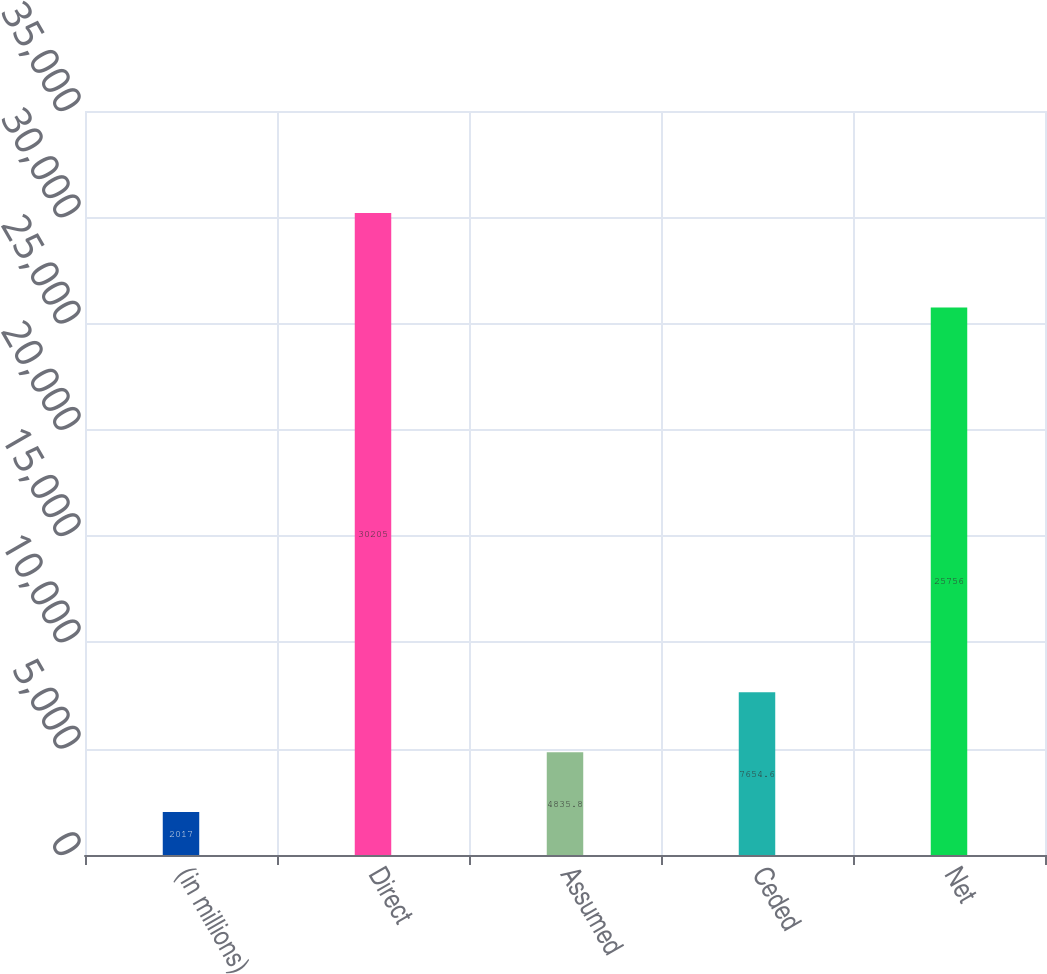Convert chart. <chart><loc_0><loc_0><loc_500><loc_500><bar_chart><fcel>(in millions)<fcel>Direct<fcel>Assumed<fcel>Ceded<fcel>Net<nl><fcel>2017<fcel>30205<fcel>4835.8<fcel>7654.6<fcel>25756<nl></chart> 